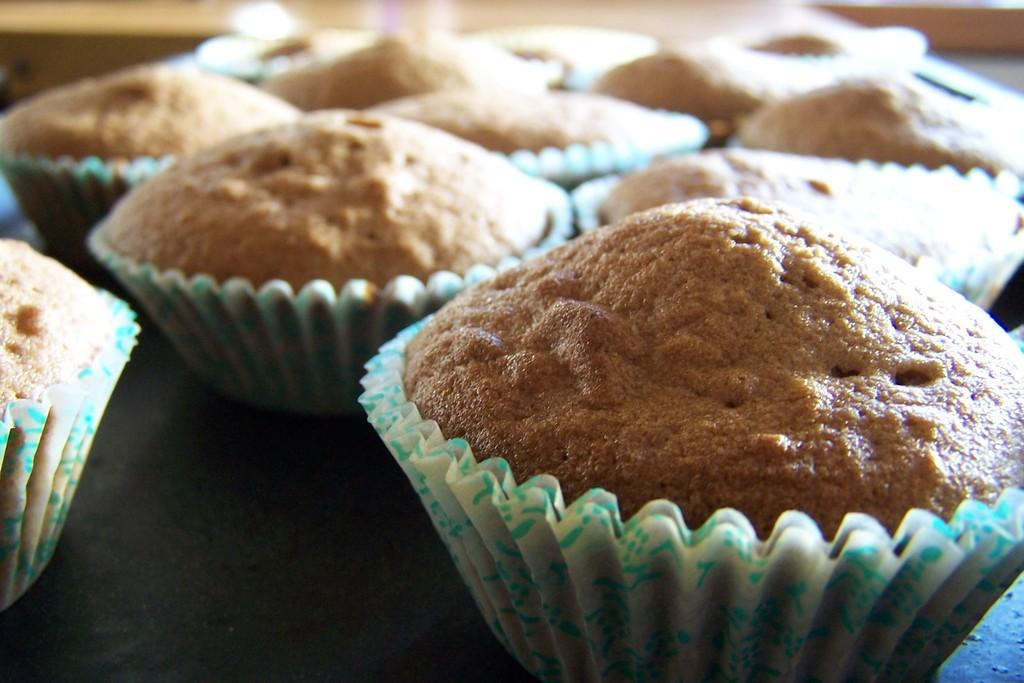What type of food is visible in the image? There are cupcakes in the image. Where are the cupcakes located? The cupcakes are on a table. What type of pets can be seen playing with the cupcakes in the image? There are no pets present in the image, and the cupcakes are not being played with. 